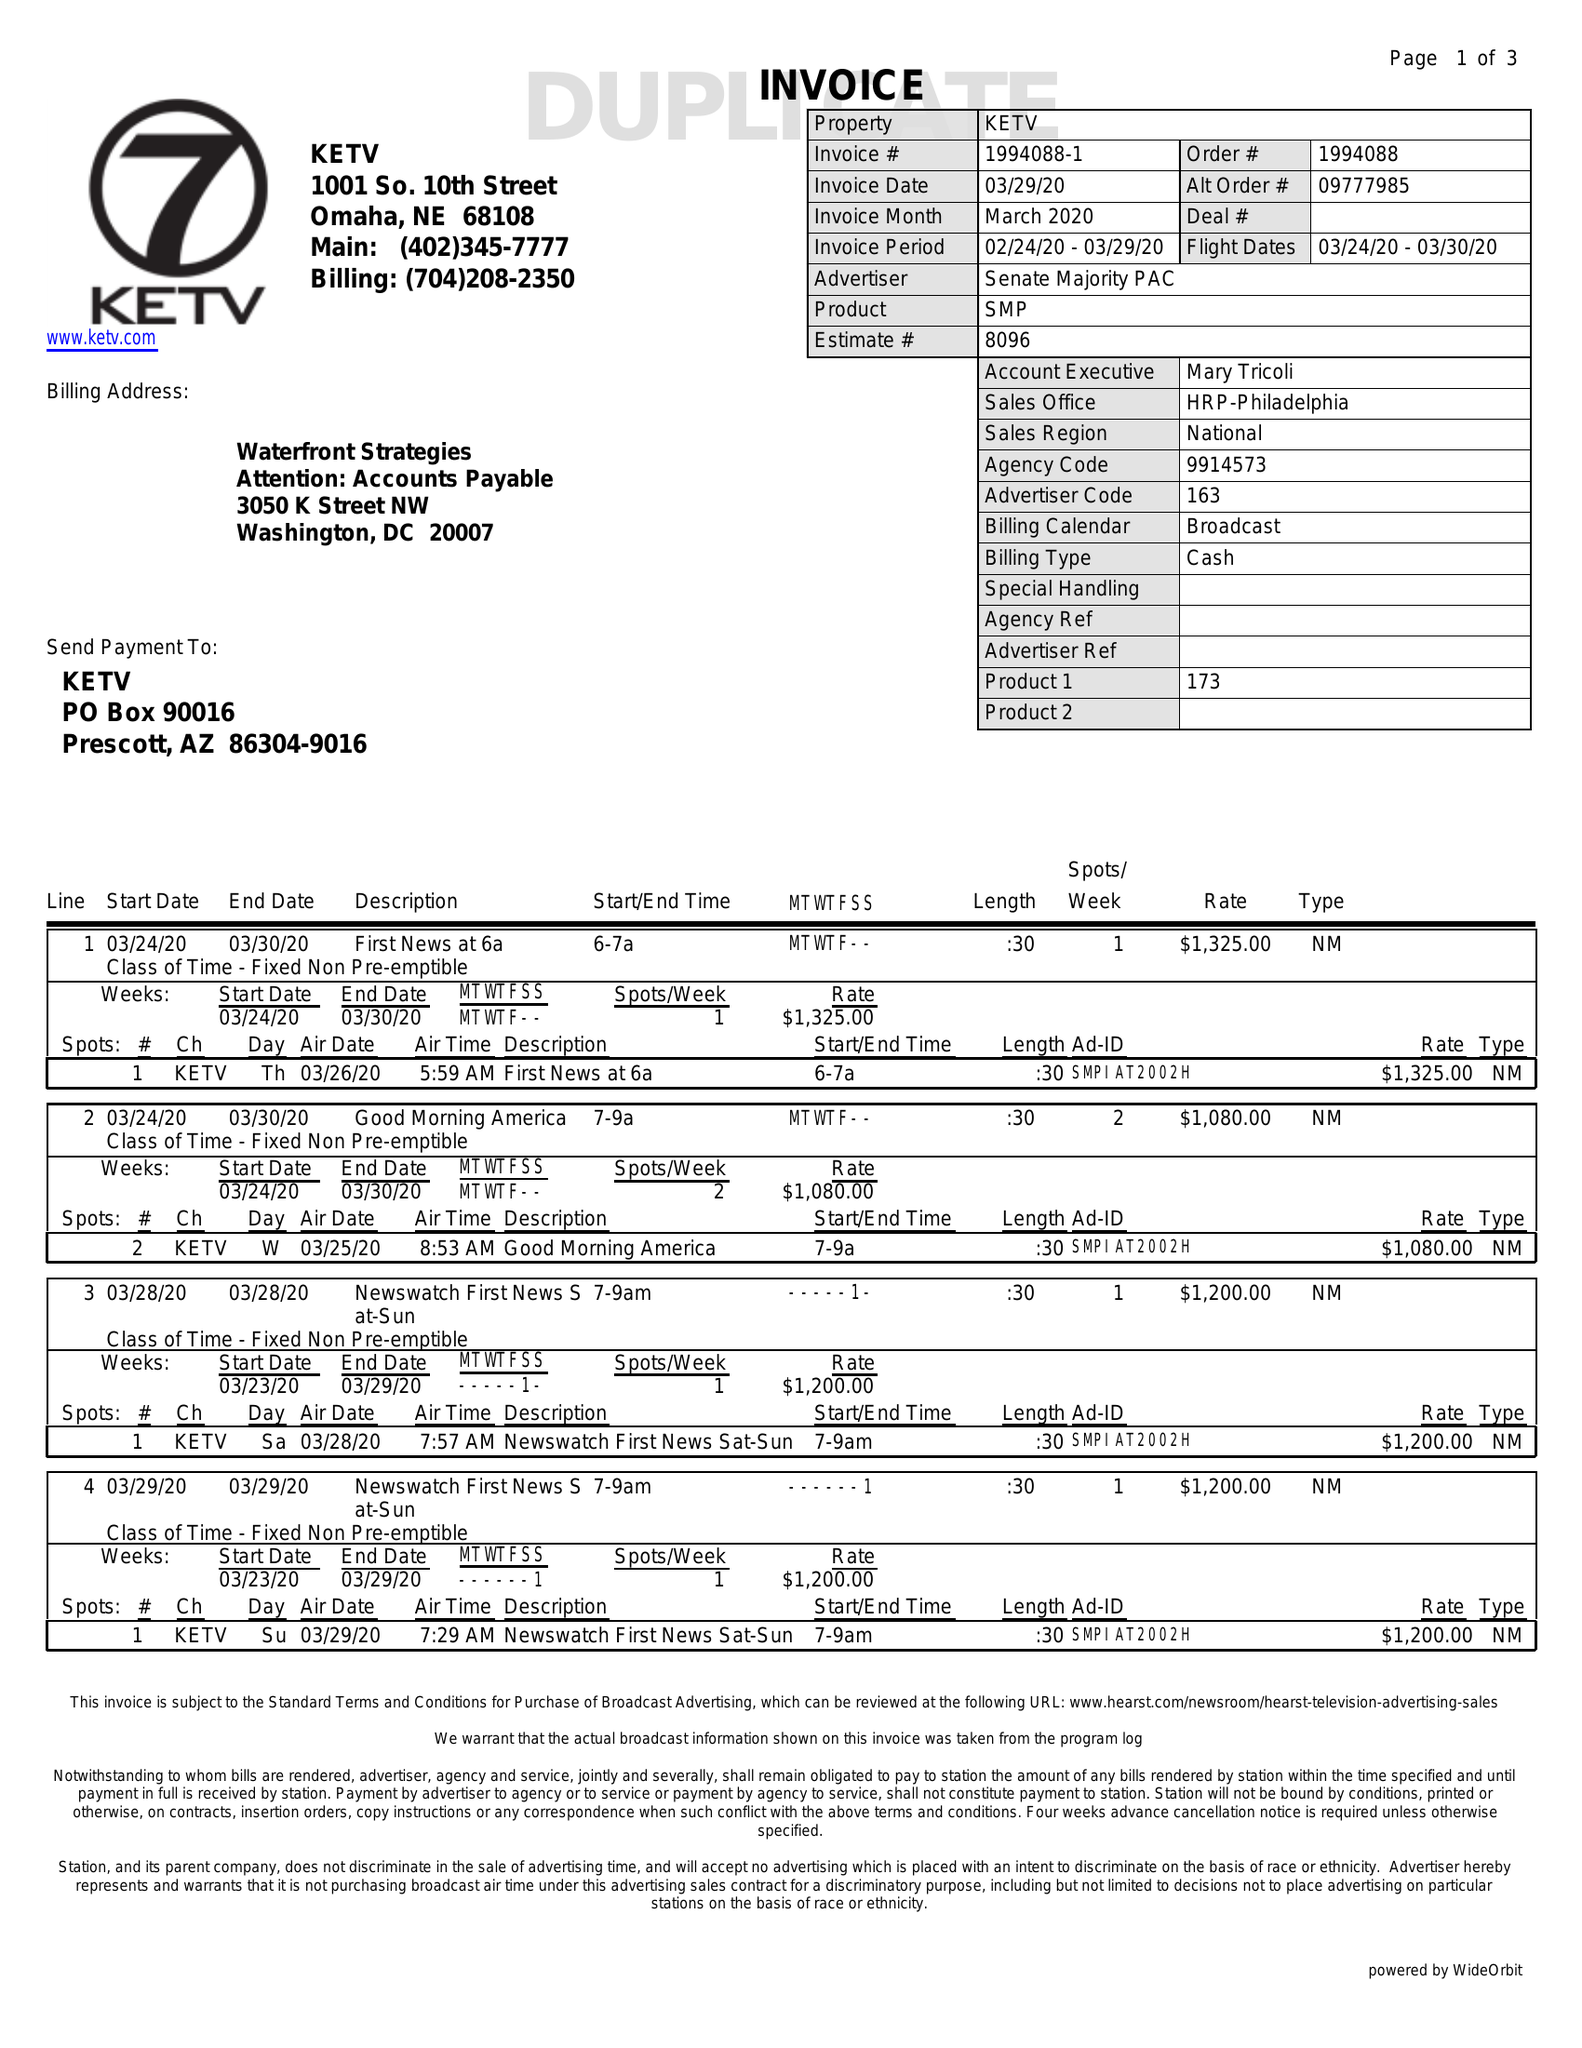What is the value for the gross_amount?
Answer the question using a single word or phrase. 17470.00 